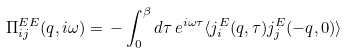Convert formula to latex. <formula><loc_0><loc_0><loc_500><loc_500>\Pi _ { i j } ^ { E E } ( q , i \omega ) = \, - \int _ { 0 } ^ { \beta } d \tau \, e ^ { i \omega \tau } \langle j _ { i } ^ { E } ( q , \tau ) j _ { j } ^ { E } ( - q , 0 ) \rangle</formula> 